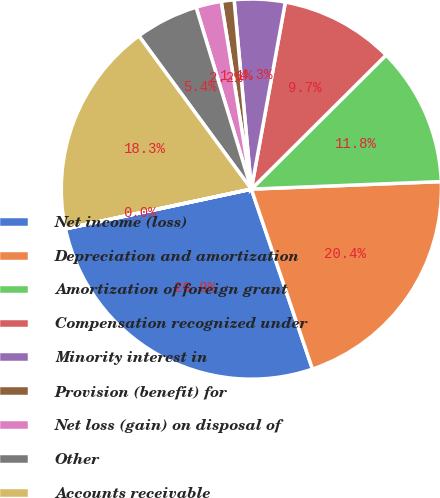<chart> <loc_0><loc_0><loc_500><loc_500><pie_chart><fcel>Net income (loss)<fcel>Depreciation and amortization<fcel>Amortization of foreign grant<fcel>Compensation recognized under<fcel>Minority interest in<fcel>Provision (benefit) for<fcel>Net loss (gain) on disposal of<fcel>Other<fcel>Accounts receivable<fcel>Inventories<nl><fcel>26.86%<fcel>20.42%<fcel>11.83%<fcel>9.68%<fcel>4.31%<fcel>1.09%<fcel>2.16%<fcel>5.38%<fcel>18.27%<fcel>0.01%<nl></chart> 